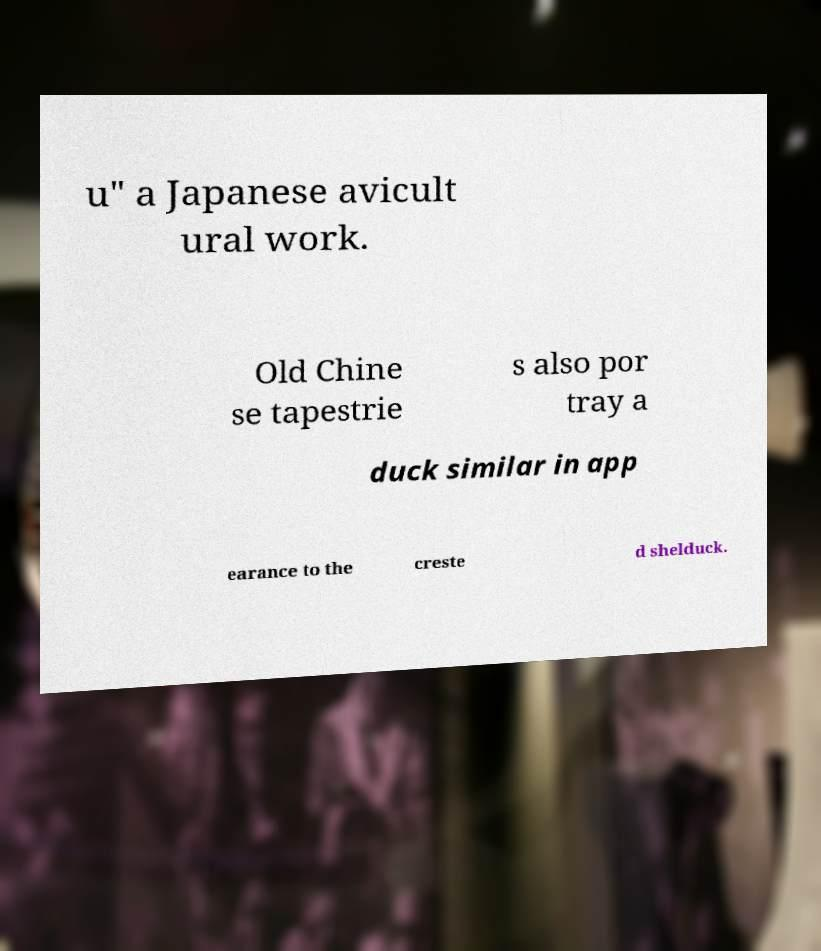What messages or text are displayed in this image? I need them in a readable, typed format. u" a Japanese avicult ural work. Old Chine se tapestrie s also por tray a duck similar in app earance to the creste d shelduck. 